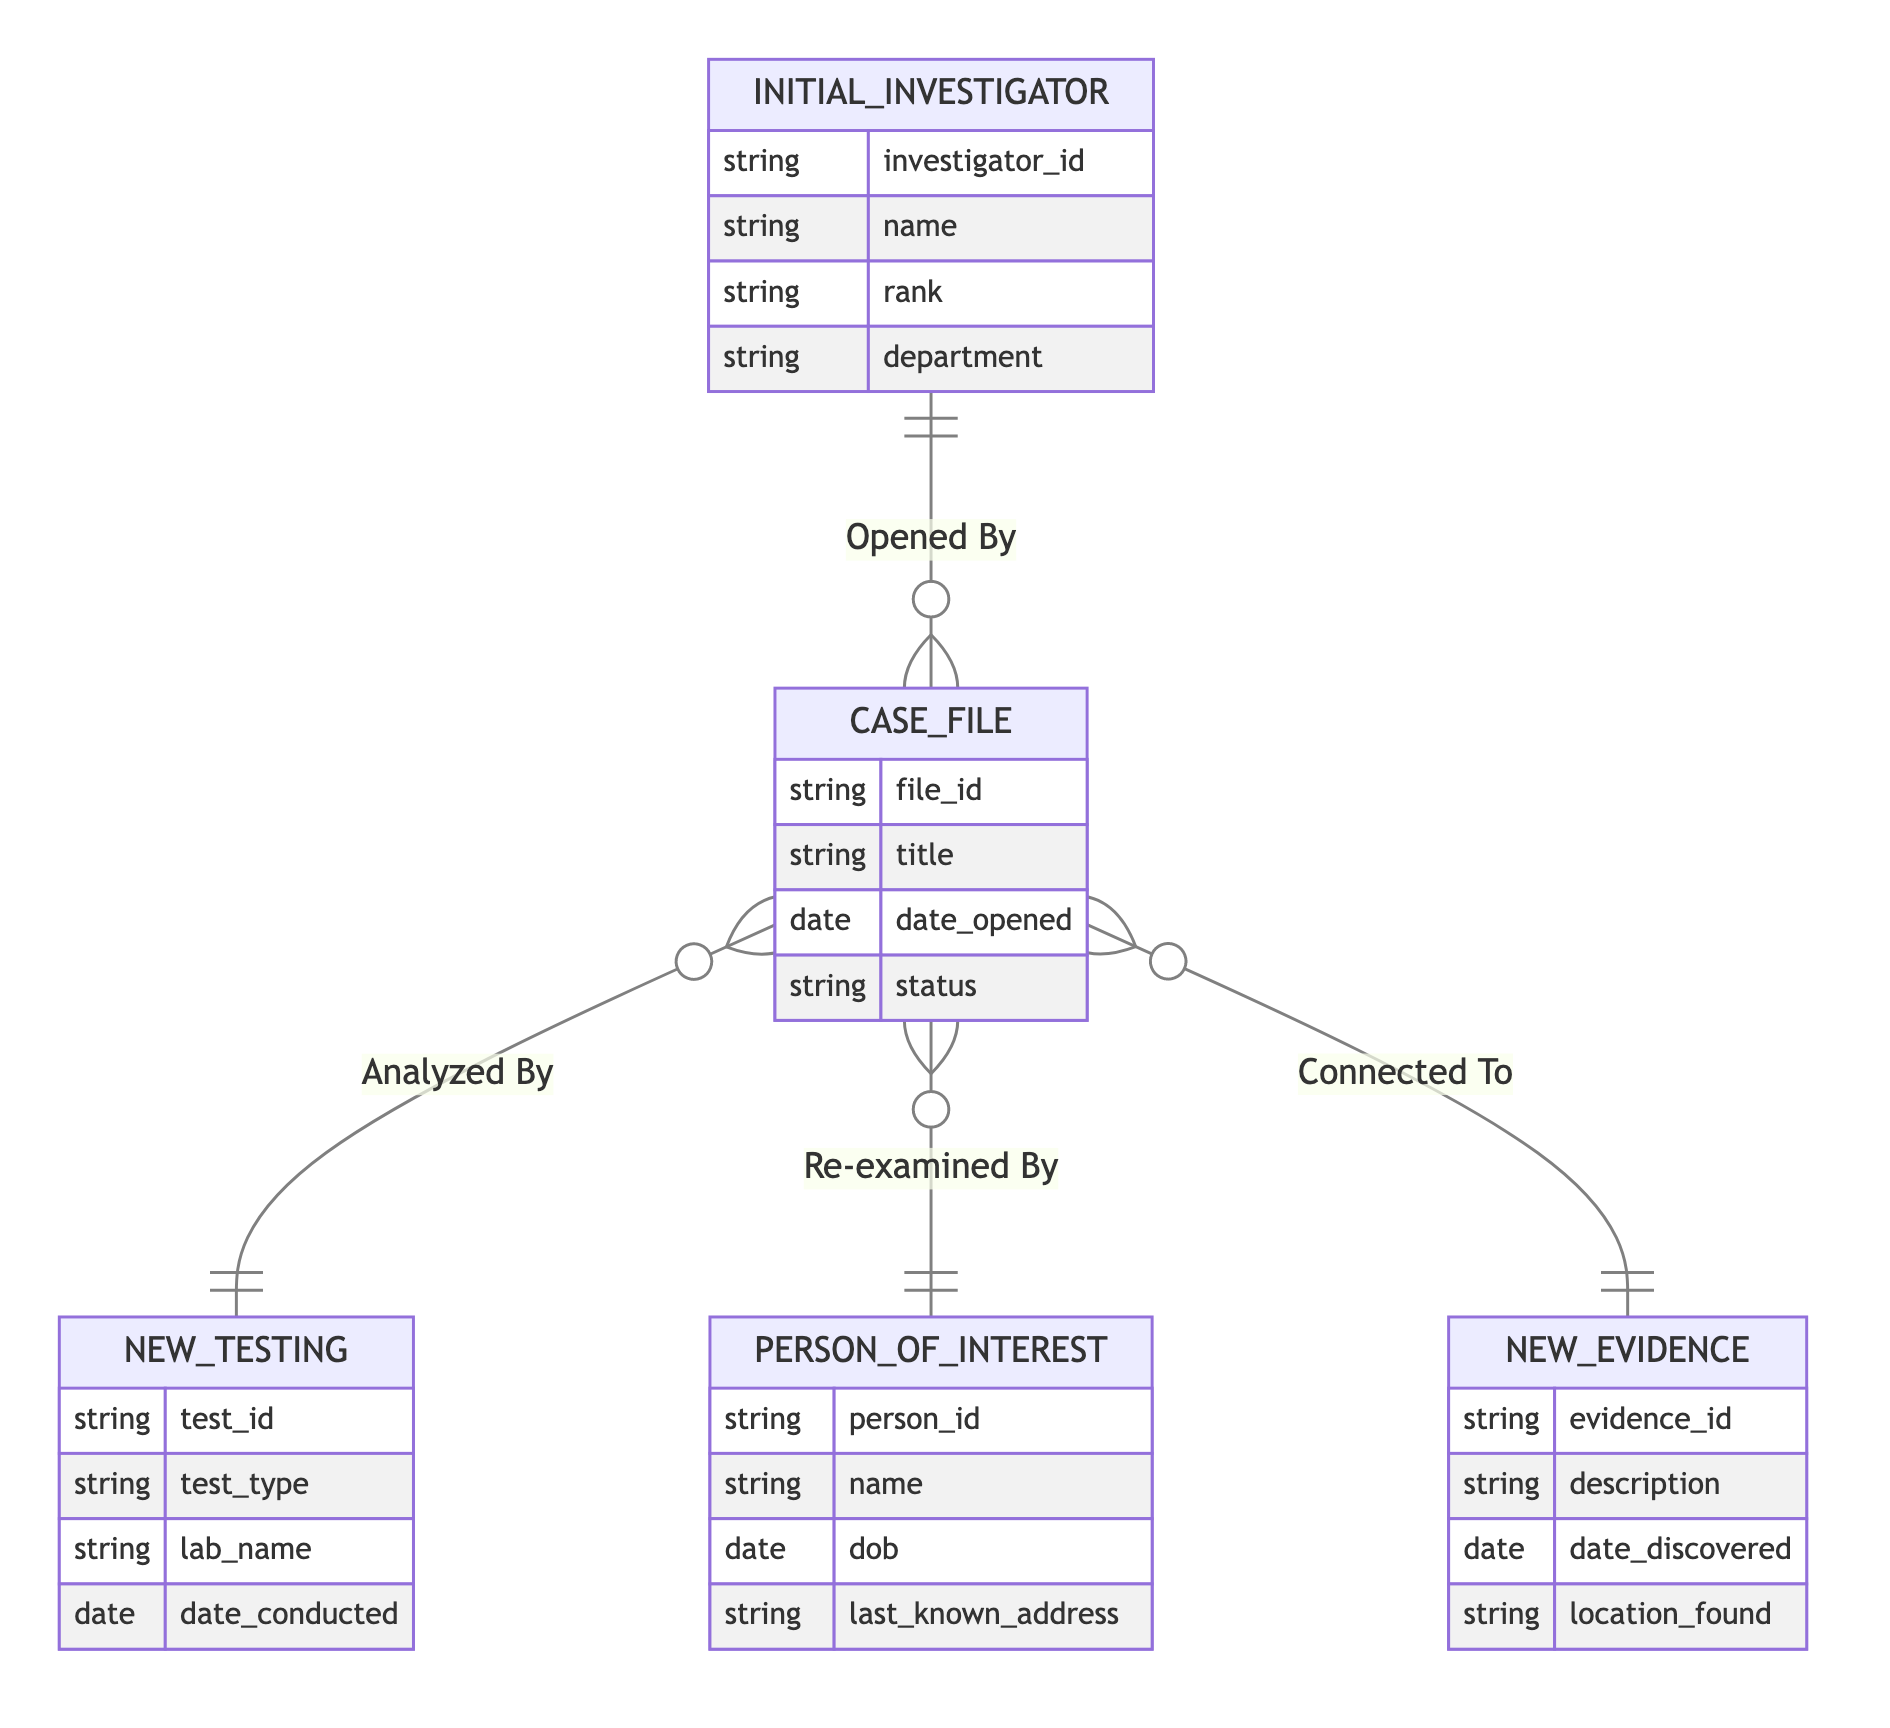What's the relationship between Initial Investigator and Case File? The diagram shows the relationship "Opened By" connecting the Initial Investigator to the Case File, indicating that a specific investigator is responsible for opening that case file.
Answer: Opened By How many entities are in the diagram? By counting the sections labeled as entities in the diagram, we see five distinct ones: Initial Investigator, Case File, New Testing, Person of Interest, and New Evidence.
Answer: Five What entity analyzes New Testing? The diagram indicates that New Testing is analyzed by the Case File, showing a direct relationship labeled "Analyzed By" that connects them.
Answer: Case File Which entity is connected to New Evidence? The relationship named "Connected To" shows that the Case File is connected to New Evidence, indicating that one case can be linked with multiple pieces of evidence.
Answer: Case File Which entity has the most relationships in the diagram? Upon examining the diagram, we can see that the Case File connects to four other entities through different relationships, making it the one with the most connections.
Answer: Case File What is a common role of the Initial Investigator? The role of the Initial Investigator is to open the case file, as indicated by the relationship "Opened By" that connects them directly.
Answer: Open Which attribute belongs to the Person of Interest entity? The Person of Interest entity has attributes such as person_id, name, dob, and last_known_address; any of these can be identified as belonging to this entity.
Answer: person_id What is the significance of the "Re-examined By" relationship? This relationship indicates that the Case File can be revisited with regards to a Person of Interest, suggesting an ongoing investigation or new insights into the person involved.
Answer: Ongoing investigation How does New Testing relate to the Case File? The diagram describes this relationship as "Analyzed By," meaning that the results of the New Testing are used to draw conclusions or insights relevant to the Case File.
Answer: Analyzed By 